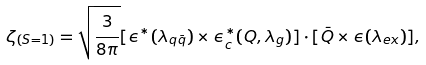<formula> <loc_0><loc_0><loc_500><loc_500>\zeta _ { ( S = 1 ) } = \sqrt { \frac { 3 } { 8 \pi } } [ { \epsilon } ^ { \ast } ( \lambda _ { q \bar { q } } ) \times { \epsilon } _ { c } ^ { \ast } ( { Q } , \lambda _ { g } ) ] \cdot [ \bar { Q } \times { \epsilon } ( \lambda _ { e x } ) ] ,</formula> 